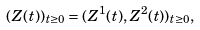<formula> <loc_0><loc_0><loc_500><loc_500>( Z ( t ) ) _ { t \geq 0 } = ( Z ^ { 1 } ( t ) , Z ^ { 2 } ( t ) ) _ { t \geq 0 } ,</formula> 